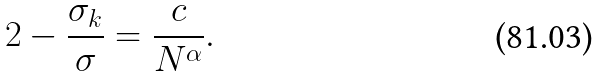Convert formula to latex. <formula><loc_0><loc_0><loc_500><loc_500>2 - \frac { \sigma _ { k } } { \sigma } = \frac { c } { N ^ { \alpha } } .</formula> 